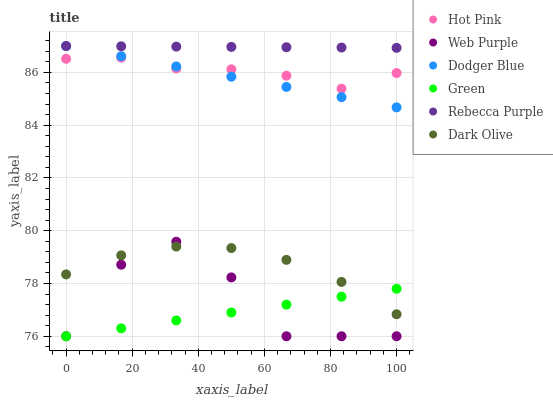Does Green have the minimum area under the curve?
Answer yes or no. Yes. Does Rebecca Purple have the maximum area under the curve?
Answer yes or no. Yes. Does Dark Olive have the minimum area under the curve?
Answer yes or no. No. Does Dark Olive have the maximum area under the curve?
Answer yes or no. No. Is Rebecca Purple the smoothest?
Answer yes or no. Yes. Is Web Purple the roughest?
Answer yes or no. Yes. Is Dark Olive the smoothest?
Answer yes or no. No. Is Dark Olive the roughest?
Answer yes or no. No. Does Web Purple have the lowest value?
Answer yes or no. Yes. Does Dark Olive have the lowest value?
Answer yes or no. No. Does Dodger Blue have the highest value?
Answer yes or no. Yes. Does Dark Olive have the highest value?
Answer yes or no. No. Is Hot Pink less than Rebecca Purple?
Answer yes or no. Yes. Is Rebecca Purple greater than Green?
Answer yes or no. Yes. Does Web Purple intersect Dark Olive?
Answer yes or no. Yes. Is Web Purple less than Dark Olive?
Answer yes or no. No. Is Web Purple greater than Dark Olive?
Answer yes or no. No. Does Hot Pink intersect Rebecca Purple?
Answer yes or no. No. 